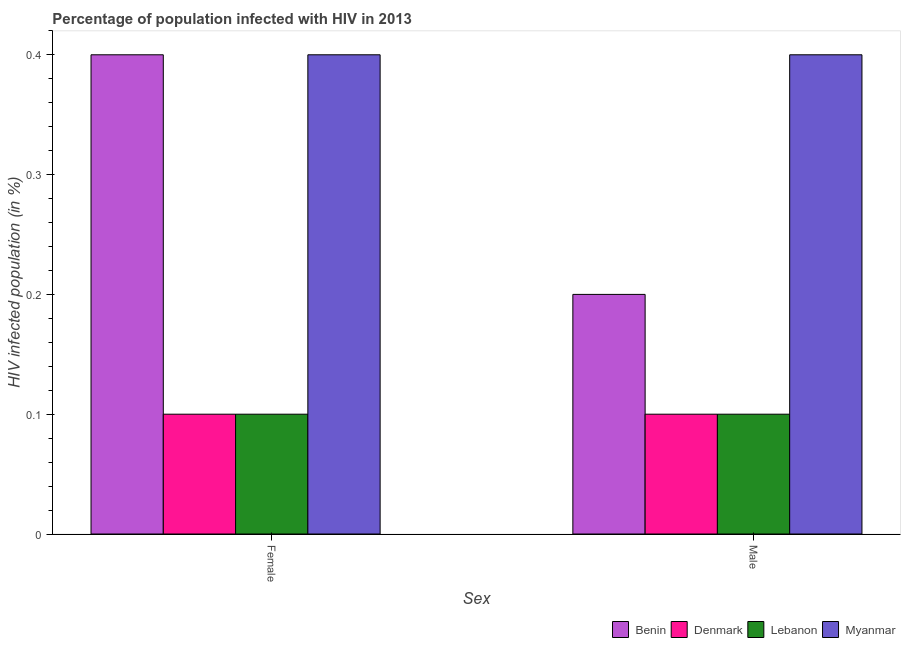Are the number of bars per tick equal to the number of legend labels?
Your response must be concise. Yes. Are the number of bars on each tick of the X-axis equal?
Give a very brief answer. Yes. How many bars are there on the 1st tick from the right?
Offer a terse response. 4. Across all countries, what is the maximum percentage of males who are infected with hiv?
Keep it short and to the point. 0.4. In which country was the percentage of females who are infected with hiv maximum?
Offer a very short reply. Benin. What is the total percentage of females who are infected with hiv in the graph?
Offer a terse response. 1. What is the difference between the percentage of males who are infected with hiv in Benin and the percentage of females who are infected with hiv in Myanmar?
Keep it short and to the point. -0.2. What is the average percentage of females who are infected with hiv per country?
Your response must be concise. 0.25. In how many countries, is the percentage of females who are infected with hiv greater than 0.24000000000000002 %?
Offer a very short reply. 2. What is the ratio of the percentage of males who are infected with hiv in Benin to that in Denmark?
Provide a succinct answer. 2. Is the percentage of females who are infected with hiv in Denmark less than that in Myanmar?
Make the answer very short. Yes. In how many countries, is the percentage of females who are infected with hiv greater than the average percentage of females who are infected with hiv taken over all countries?
Keep it short and to the point. 2. What does the 1st bar from the right in Female represents?
Provide a short and direct response. Myanmar. How many bars are there?
Provide a succinct answer. 8. Are all the bars in the graph horizontal?
Your answer should be very brief. No. How many countries are there in the graph?
Your answer should be compact. 4. What is the difference between two consecutive major ticks on the Y-axis?
Make the answer very short. 0.1. What is the title of the graph?
Your answer should be very brief. Percentage of population infected with HIV in 2013. Does "Korea (Democratic)" appear as one of the legend labels in the graph?
Ensure brevity in your answer.  No. What is the label or title of the X-axis?
Provide a short and direct response. Sex. What is the label or title of the Y-axis?
Ensure brevity in your answer.  HIV infected population (in %). What is the HIV infected population (in %) in Benin in Female?
Provide a short and direct response. 0.4. What is the HIV infected population (in %) of Denmark in Female?
Provide a short and direct response. 0.1. What is the HIV infected population (in %) of Lebanon in Female?
Offer a very short reply. 0.1. What is the HIV infected population (in %) of Myanmar in Female?
Your response must be concise. 0.4. What is the HIV infected population (in %) in Benin in Male?
Ensure brevity in your answer.  0.2. What is the HIV infected population (in %) of Denmark in Male?
Your answer should be very brief. 0.1. What is the HIV infected population (in %) of Lebanon in Male?
Offer a very short reply. 0.1. Across all Sex, what is the minimum HIV infected population (in %) of Denmark?
Offer a very short reply. 0.1. What is the total HIV infected population (in %) in Benin in the graph?
Offer a terse response. 0.6. What is the difference between the HIV infected population (in %) in Myanmar in Female and that in Male?
Provide a short and direct response. 0. What is the difference between the HIV infected population (in %) in Benin in Female and the HIV infected population (in %) in Myanmar in Male?
Provide a succinct answer. 0. What is the average HIV infected population (in %) of Benin per Sex?
Provide a succinct answer. 0.3. What is the average HIV infected population (in %) in Lebanon per Sex?
Provide a succinct answer. 0.1. What is the difference between the HIV infected population (in %) of Benin and HIV infected population (in %) of Denmark in Female?
Give a very brief answer. 0.3. What is the difference between the HIV infected population (in %) in Benin and HIV infected population (in %) in Lebanon in Female?
Offer a very short reply. 0.3. What is the difference between the HIV infected population (in %) of Denmark and HIV infected population (in %) of Myanmar in Female?
Provide a short and direct response. -0.3. What is the difference between the HIV infected population (in %) of Lebanon and HIV infected population (in %) of Myanmar in Female?
Your answer should be very brief. -0.3. What is the difference between the HIV infected population (in %) in Benin and HIV infected population (in %) in Lebanon in Male?
Provide a succinct answer. 0.1. What is the difference between the HIV infected population (in %) of Benin and HIV infected population (in %) of Myanmar in Male?
Ensure brevity in your answer.  -0.2. What is the difference between the HIV infected population (in %) in Denmark and HIV infected population (in %) in Lebanon in Male?
Make the answer very short. 0. What is the ratio of the HIV infected population (in %) of Benin in Female to that in Male?
Offer a very short reply. 2. What is the ratio of the HIV infected population (in %) in Myanmar in Female to that in Male?
Keep it short and to the point. 1. What is the difference between the highest and the second highest HIV infected population (in %) of Benin?
Give a very brief answer. 0.2. What is the difference between the highest and the second highest HIV infected population (in %) of Lebanon?
Give a very brief answer. 0. 